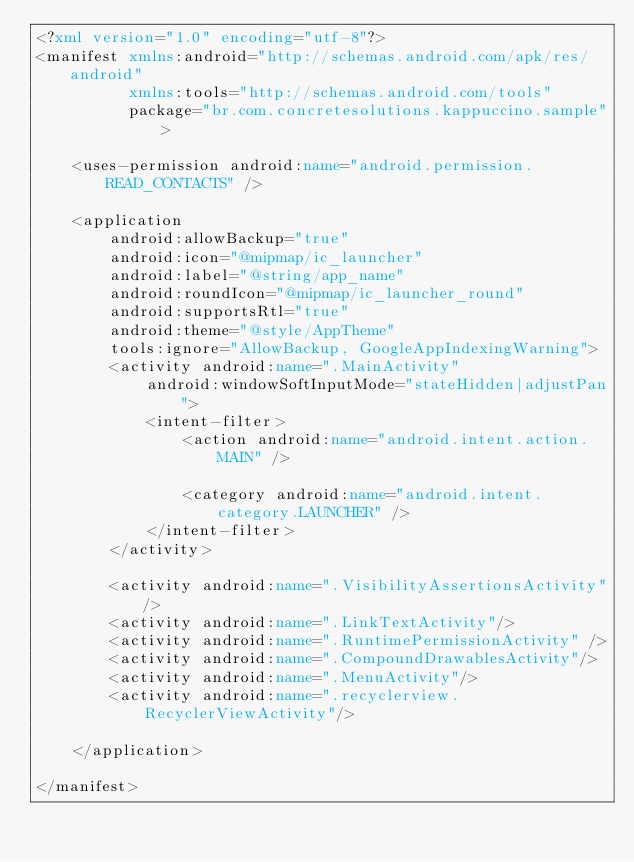<code> <loc_0><loc_0><loc_500><loc_500><_XML_><?xml version="1.0" encoding="utf-8"?>
<manifest xmlns:android="http://schemas.android.com/apk/res/android"
          xmlns:tools="http://schemas.android.com/tools"
          package="br.com.concretesolutions.kappuccino.sample">

    <uses-permission android:name="android.permission.READ_CONTACTS" />

    <application
        android:allowBackup="true"
        android:icon="@mipmap/ic_launcher"
        android:label="@string/app_name"
        android:roundIcon="@mipmap/ic_launcher_round"
        android:supportsRtl="true"
        android:theme="@style/AppTheme"
        tools:ignore="AllowBackup, GoogleAppIndexingWarning">
        <activity android:name=".MainActivity"
            android:windowSoftInputMode="stateHidden|adjustPan">
            <intent-filter>
                <action android:name="android.intent.action.MAIN" />

                <category android:name="android.intent.category.LAUNCHER" />
            </intent-filter>
        </activity>

        <activity android:name=".VisibilityAssertionsActivity"/>
        <activity android:name=".LinkTextActivity"/>
        <activity android:name=".RuntimePermissionActivity" />
        <activity android:name=".CompoundDrawablesActivity"/>
        <activity android:name=".MenuActivity"/>
        <activity android:name=".recyclerview.RecyclerViewActivity"/>

    </application>

</manifest></code> 